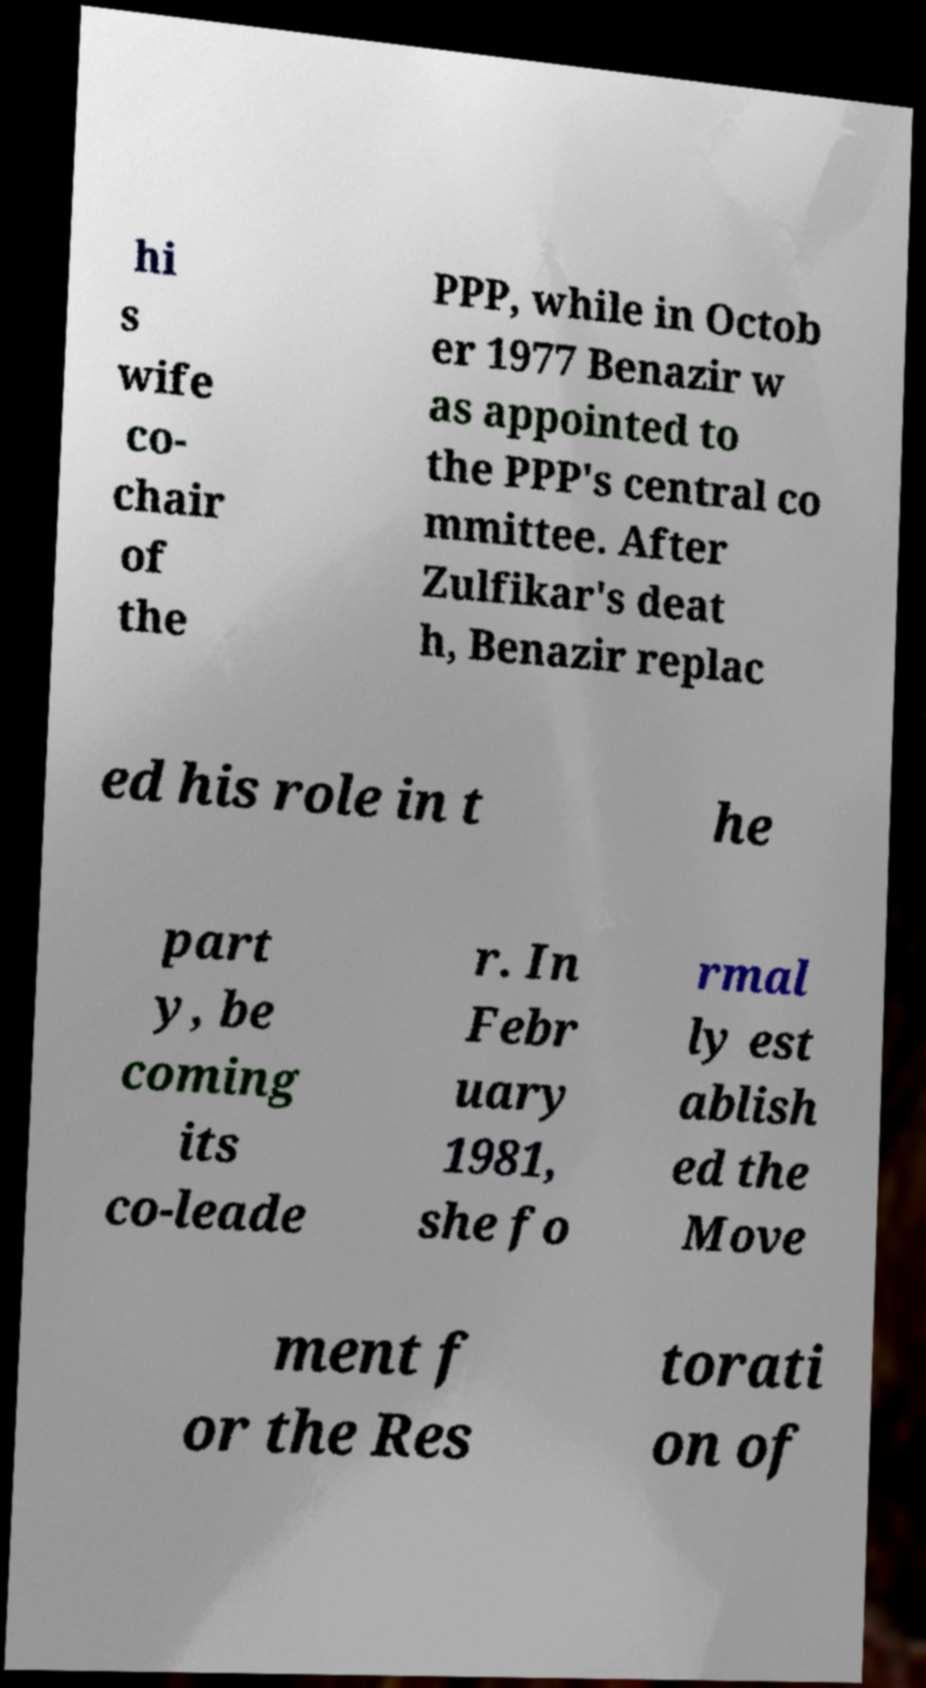Please read and relay the text visible in this image. What does it say? hi s wife co- chair of the PPP, while in Octob er 1977 Benazir w as appointed to the PPP's central co mmittee. After Zulfikar's deat h, Benazir replac ed his role in t he part y, be coming its co-leade r. In Febr uary 1981, she fo rmal ly est ablish ed the Move ment f or the Res torati on of 